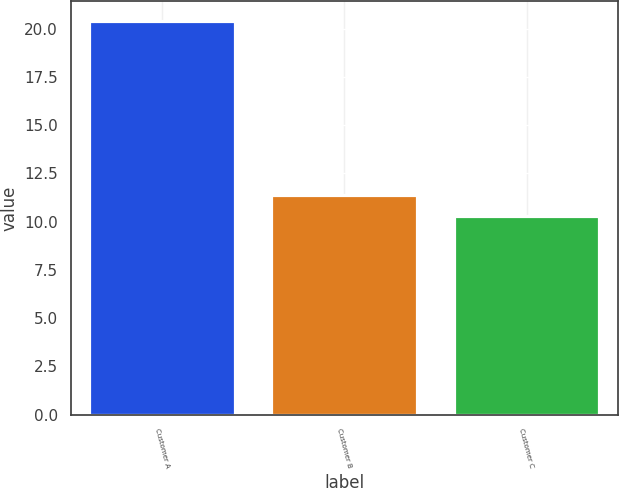Convert chart to OTSL. <chart><loc_0><loc_0><loc_500><loc_500><bar_chart><fcel>Customer A<fcel>Customer B<fcel>Customer C<nl><fcel>20.4<fcel>11.4<fcel>10.3<nl></chart> 